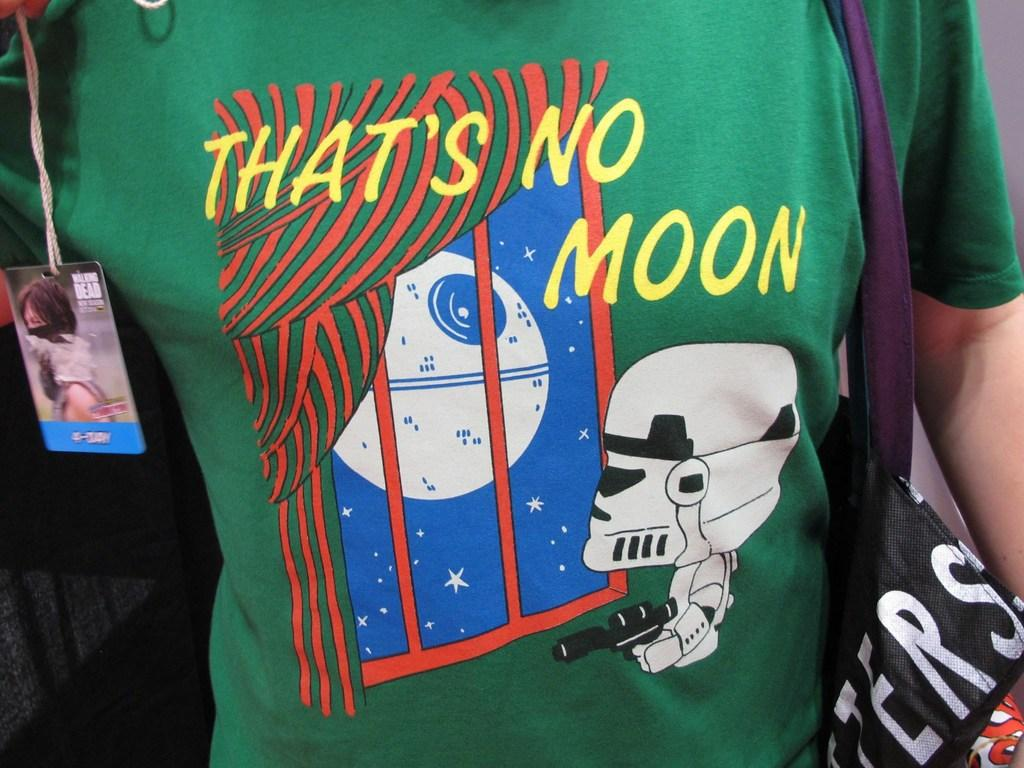<image>
Give a short and clear explanation of the subsequent image. a person with a shirt that says that's no moon 